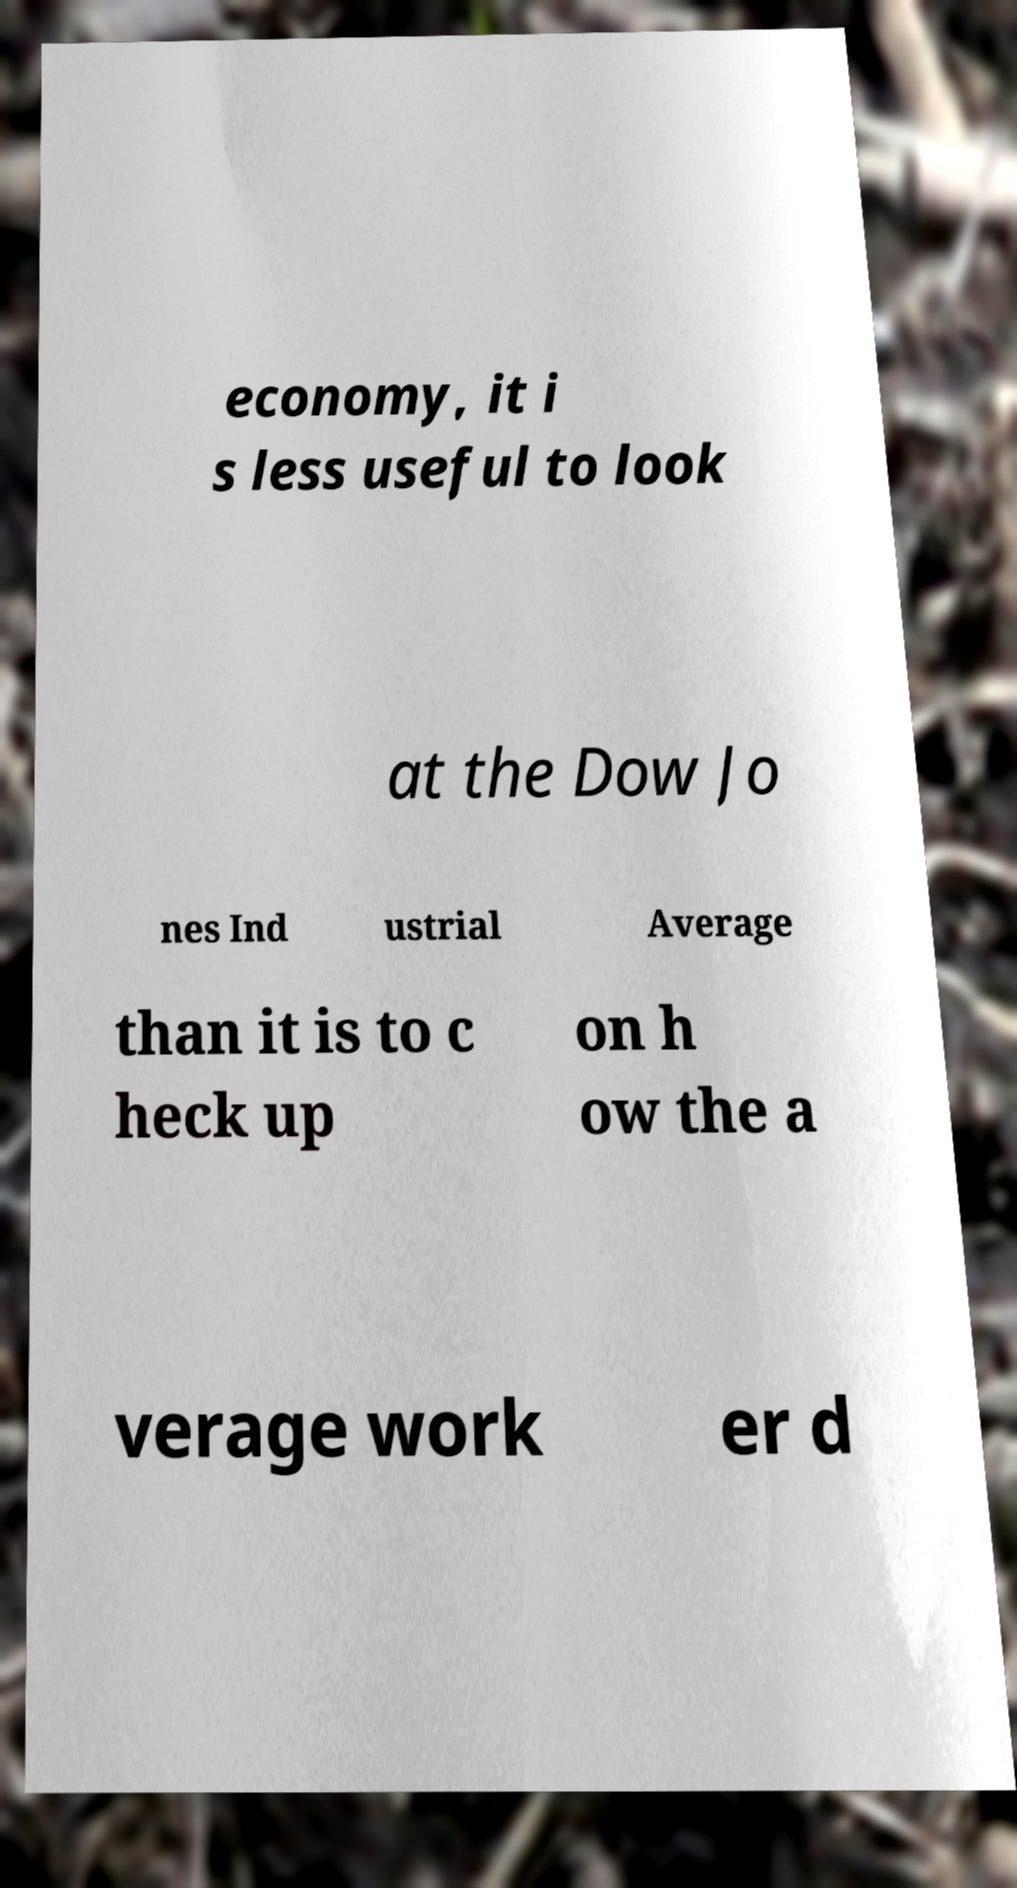There's text embedded in this image that I need extracted. Can you transcribe it verbatim? economy, it i s less useful to look at the Dow Jo nes Ind ustrial Average than it is to c heck up on h ow the a verage work er d 